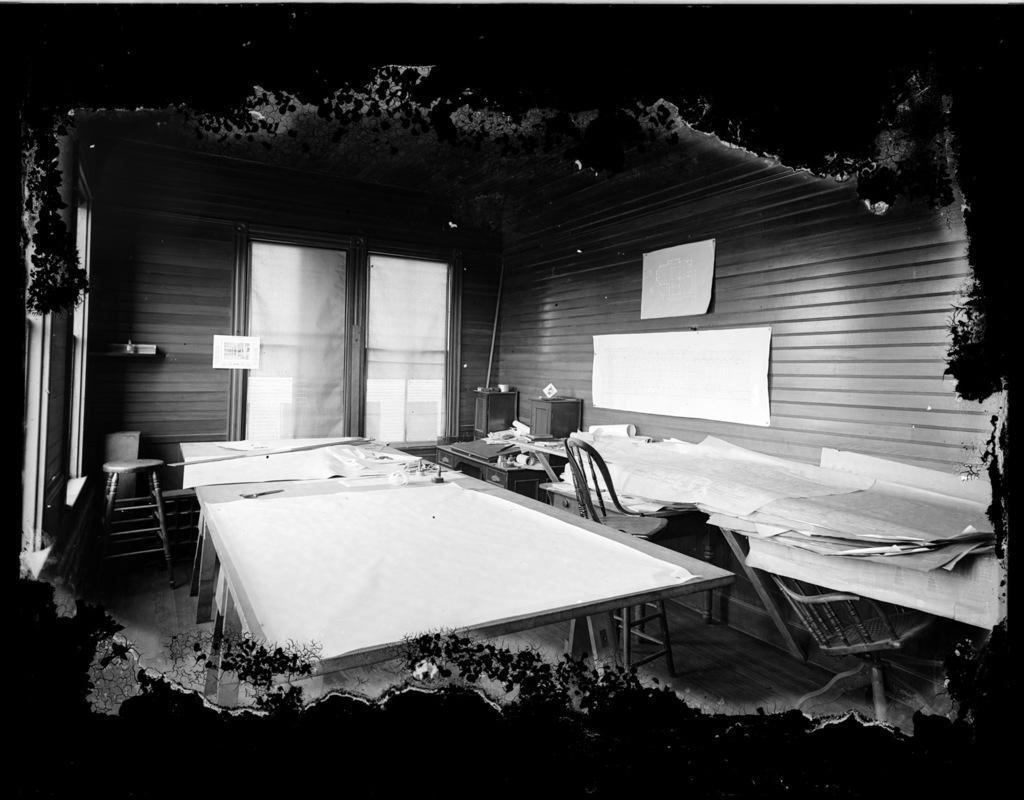Can you describe this image briefly? This picture describes about inside view of a room, in the room we can see few chairs and papers on the tables, in the background we can see posters on the wall. 